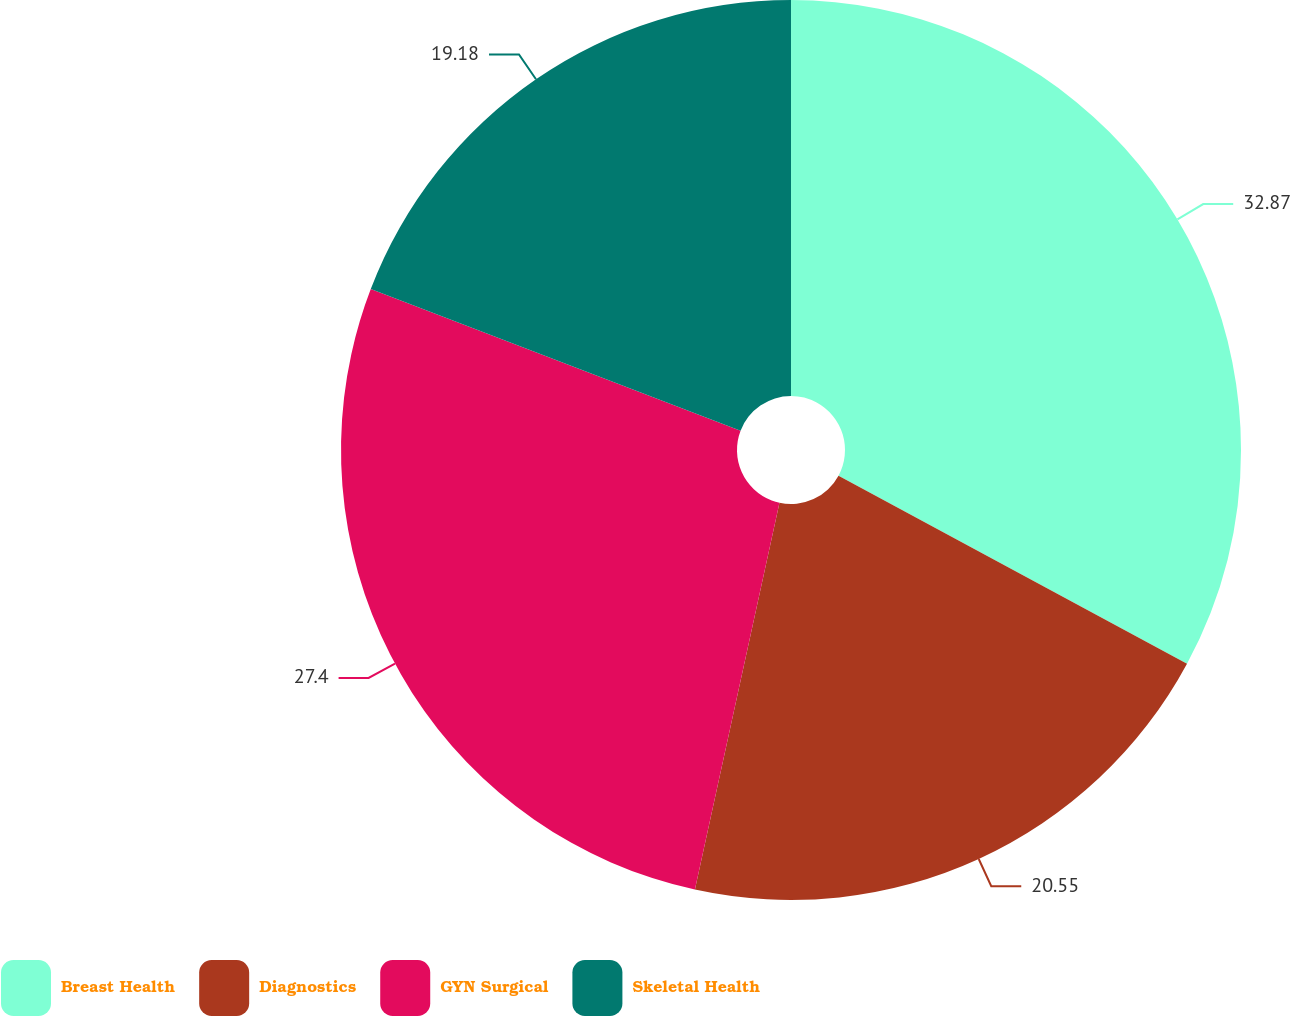Convert chart to OTSL. <chart><loc_0><loc_0><loc_500><loc_500><pie_chart><fcel>Breast Health<fcel>Diagnostics<fcel>GYN Surgical<fcel>Skeletal Health<nl><fcel>32.88%<fcel>20.55%<fcel>27.4%<fcel>19.18%<nl></chart> 